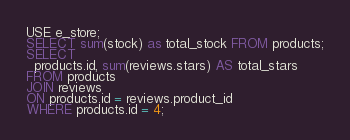Convert code to text. <code><loc_0><loc_0><loc_500><loc_500><_SQL_>USE e_store;
SELECT sum(stock) as total_stock FROM products;
SELECT
  products.id, sum(reviews.stars) AS total_stars
FROM products
JOIN reviews
ON products.id = reviews.product_id
WHERE products.id = 4;
</code> 